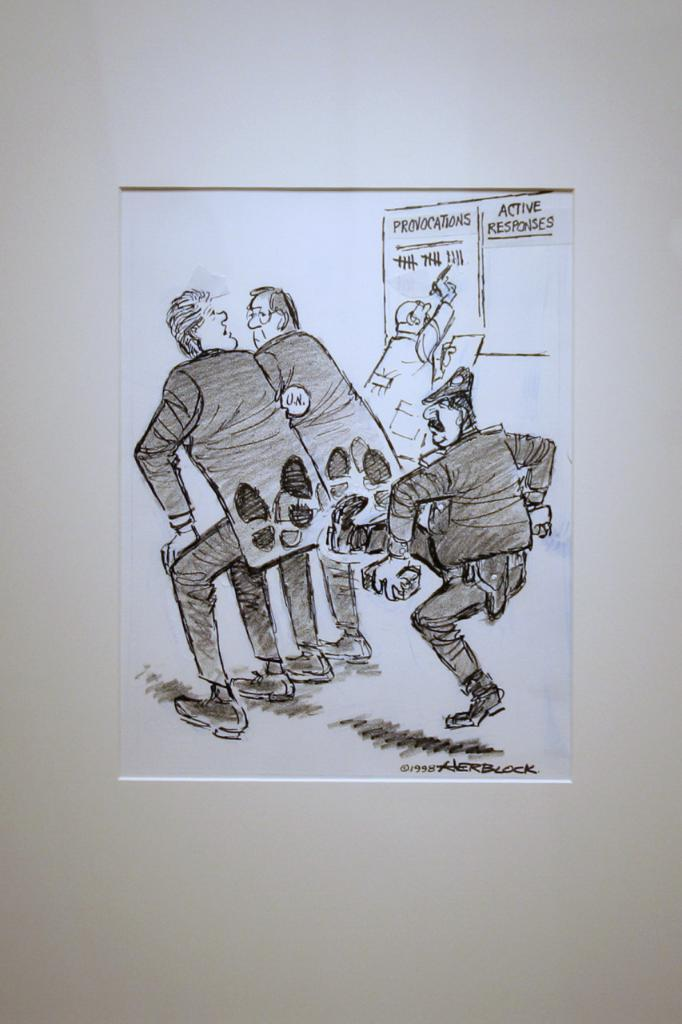What is on the wall in the image? There is a paper on the wall in the image. What is depicted on the paper? The paper depicts a person kicking two other people. Are there any words or letters on the paper? Yes, there is text on the paper. What type of mailbox is shown in the image? There is no mailbox present in the image. What kind of lumber is being used to build the person depicted on the paper? The image does not show any lumber or construction materials; it depicts a person kicking two other people. 